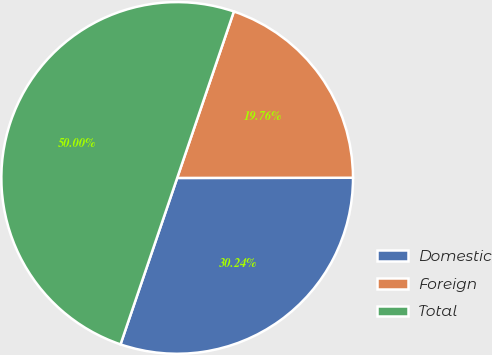Convert chart. <chart><loc_0><loc_0><loc_500><loc_500><pie_chart><fcel>Domestic<fcel>Foreign<fcel>Total<nl><fcel>30.24%<fcel>19.76%<fcel>50.0%<nl></chart> 